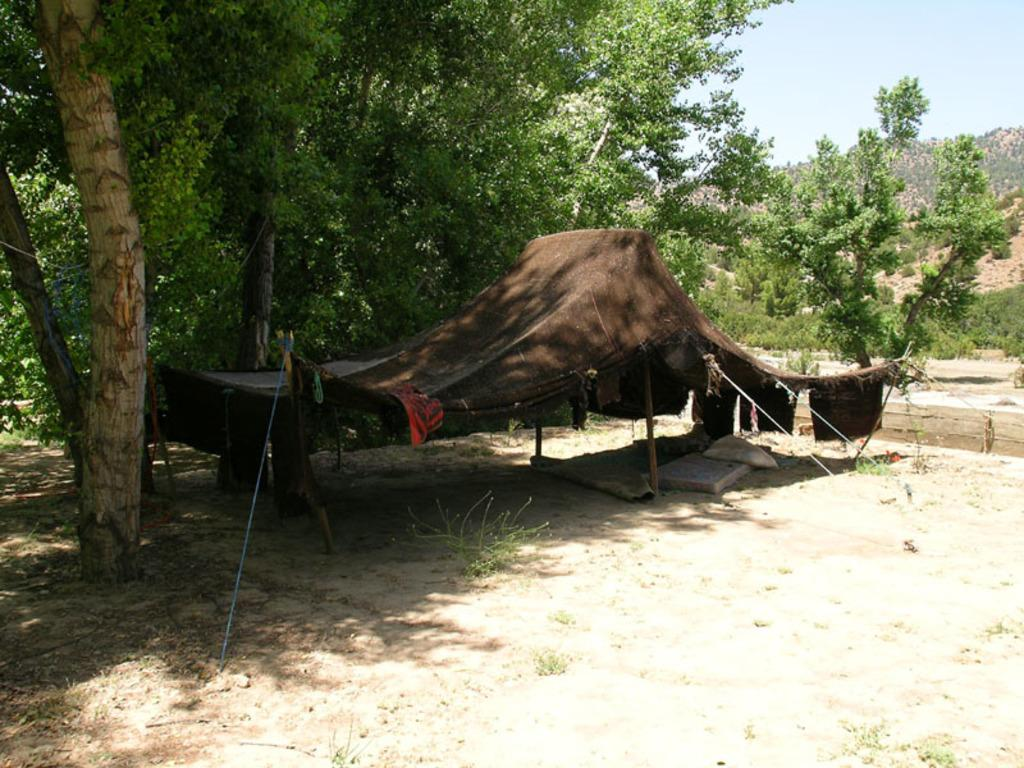What type of shelter is visible in the image? There is a brown tent in the image. How is the tent positioned in the image? The tent is built on the ground. What natural elements can be seen around the tent? Trees and plants are present around the tent. What channel is the tent tuned to in the image? There is no indication of a television or any channels in the image; it features a brown tent surrounded by trees and plants. 